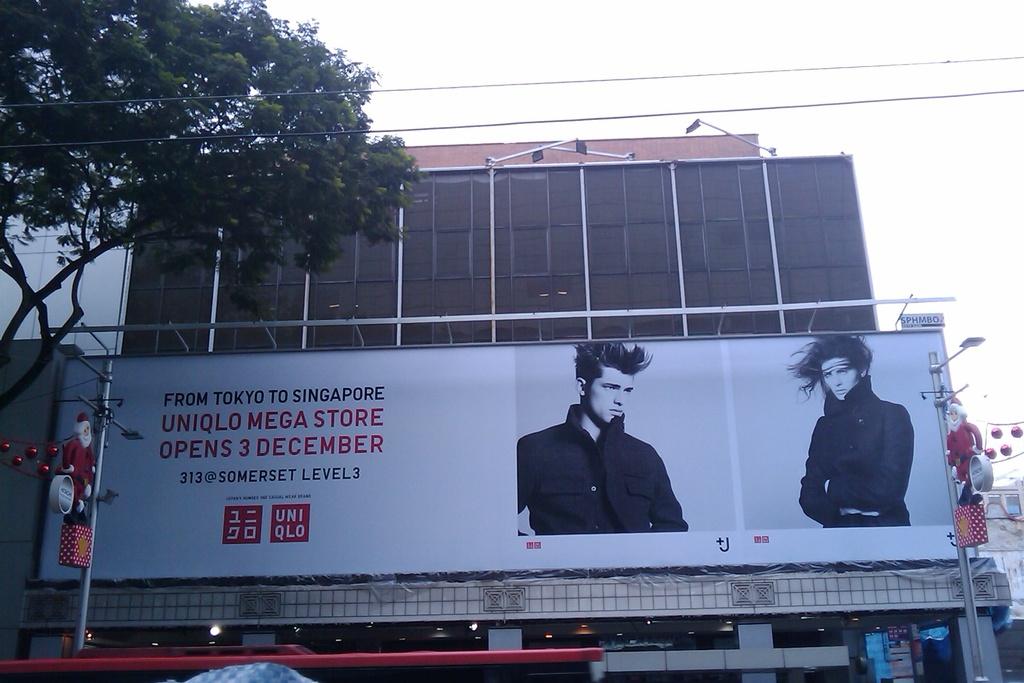What store is this advert for?
Keep it short and to the point. Uniqlo. 